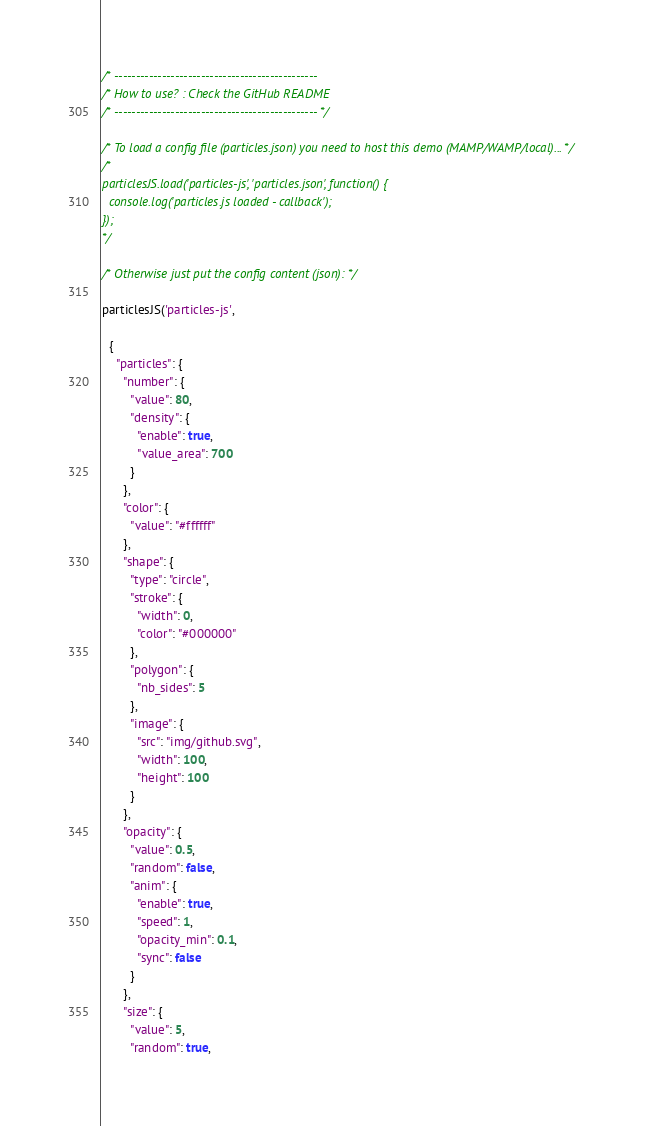Convert code to text. <code><loc_0><loc_0><loc_500><loc_500><_JavaScript_>/* -----------------------------------------------
/* How to use? : Check the GitHub README
/* ----------------------------------------------- */

/* To load a config file (particles.json) you need to host this demo (MAMP/WAMP/local)... */
/*
particlesJS.load('particles-js', 'particles.json', function() {
  console.log('particles.js loaded - callback');
});
*/

/* Otherwise just put the config content (json): */

particlesJS('particles-js',
  
  {
    "particles": {
      "number": {
        "value": 80,
        "density": {
          "enable": true,
          "value_area": 700
        }
      },
      "color": {
        "value": "#ffffff"
      },
      "shape": {
        "type": "circle",
        "stroke": {
          "width": 0,
          "color": "#000000"
        },
        "polygon": {
          "nb_sides": 5
        },
        "image": {
          "src": "img/github.svg",
          "width": 100,
          "height": 100
        }
      },
      "opacity": {
        "value": 0.5,
        "random": false,
        "anim": {
          "enable": true,
          "speed": 1,
          "opacity_min": 0.1,
          "sync": false
        }
      },
      "size": {
        "value": 5,
        "random": true,</code> 